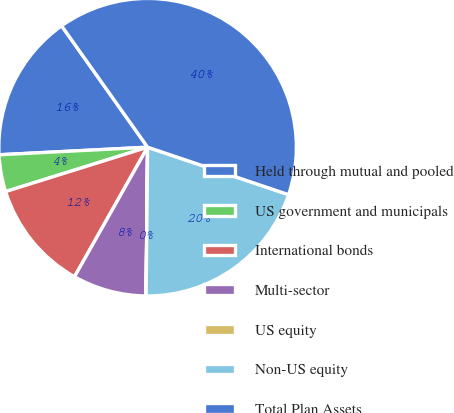Convert chart to OTSL. <chart><loc_0><loc_0><loc_500><loc_500><pie_chart><fcel>Held through mutual and pooled<fcel>US government and municipals<fcel>International bonds<fcel>Multi-sector<fcel>US equity<fcel>Non-US equity<fcel>Total Plan Assets<nl><fcel>16.0%<fcel>4.01%<fcel>12.0%<fcel>8.01%<fcel>0.01%<fcel>19.99%<fcel>39.98%<nl></chart> 